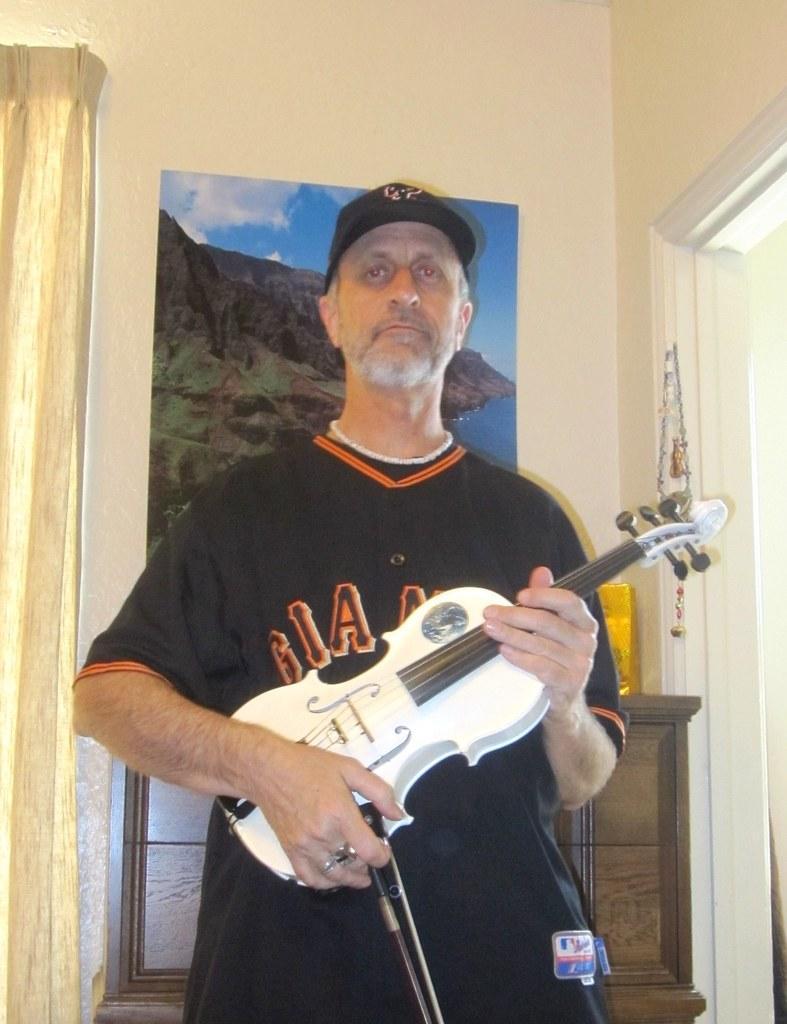Describe this image in one or two sentences. In this image there is a person wearing black color T-shirt and cap playing a violin and at the background of the image there is a scenery attached to the wall. 